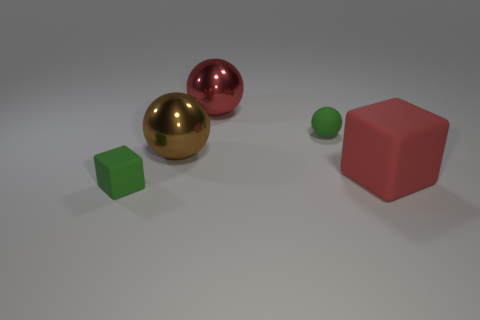What size is the green rubber thing to the right of the small green thing that is in front of the tiny thing that is behind the large rubber thing?
Give a very brief answer. Small. What size is the matte object that is the same shape as the brown shiny object?
Provide a succinct answer. Small. There is a brown ball; what number of tiny balls are left of it?
Your response must be concise. 0. There is a big metallic sphere that is in front of the green ball; does it have the same color as the tiny block?
Your answer should be compact. No. How many brown objects are large metallic balls or small things?
Your answer should be compact. 1. What is the color of the big thing that is to the right of the red thing that is behind the big brown metal thing?
Your answer should be very brief. Red. What is the material of the small thing that is the same color as the tiny matte ball?
Your answer should be compact. Rubber. The tiny object that is behind the red matte thing is what color?
Offer a terse response. Green. Do the green rubber thing that is on the left side of the brown shiny ball and the matte ball have the same size?
Make the answer very short. Yes. What size is the shiny thing that is the same color as the big matte block?
Make the answer very short. Large. 